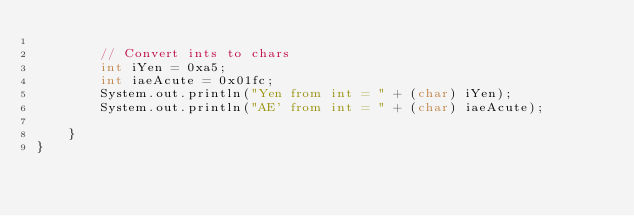<code> <loc_0><loc_0><loc_500><loc_500><_Java_>
        // Convert ints to chars
        int iYen = 0xa5;
        int iaeAcute = 0x01fc;
        System.out.println("Yen from int = " + (char) iYen);
        System.out.println("AE' from int = " + (char) iaeAcute);

    }
}
</code> 